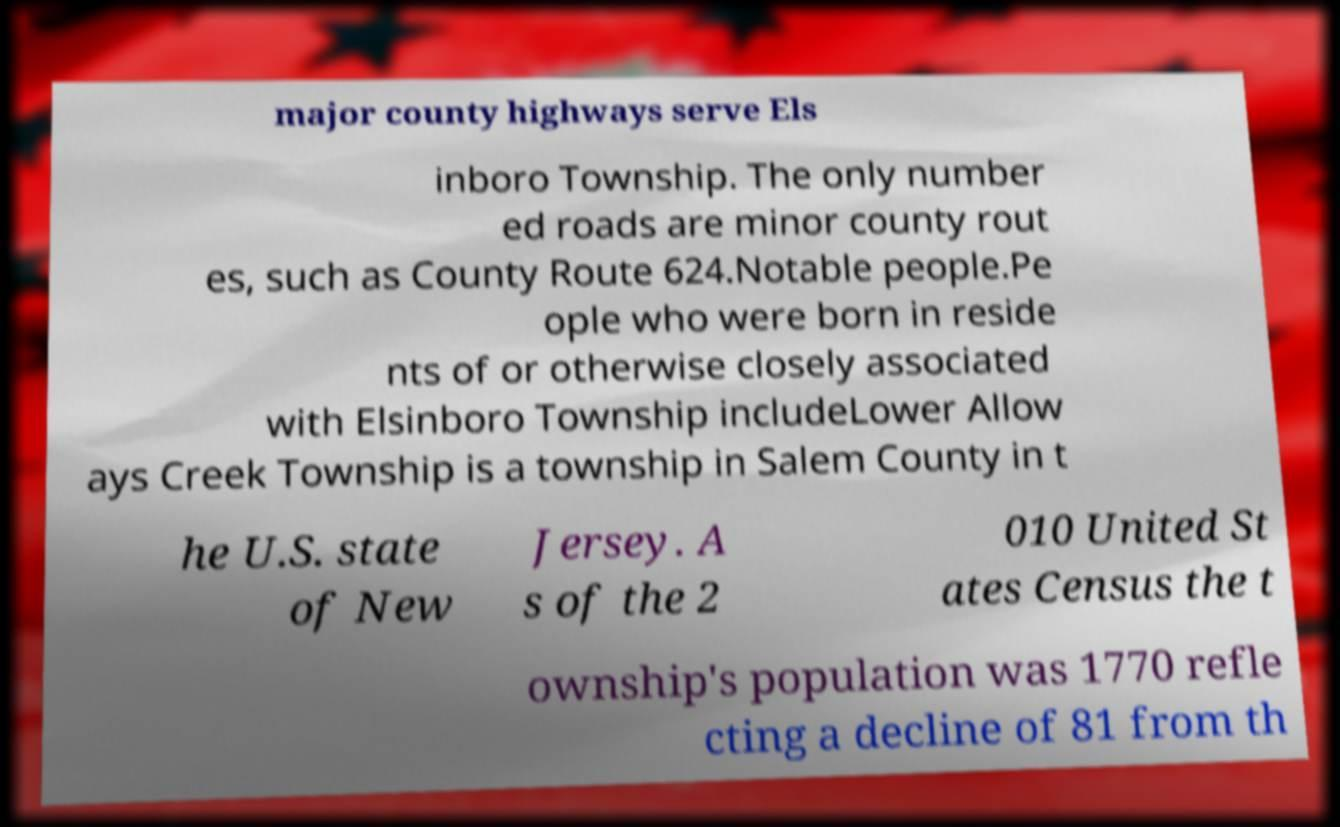Can you read and provide the text displayed in the image?This photo seems to have some interesting text. Can you extract and type it out for me? major county highways serve Els inboro Township. The only number ed roads are minor county rout es, such as County Route 624.Notable people.Pe ople who were born in reside nts of or otherwise closely associated with Elsinboro Township includeLower Allow ays Creek Township is a township in Salem County in t he U.S. state of New Jersey. A s of the 2 010 United St ates Census the t ownship's population was 1770 refle cting a decline of 81 from th 